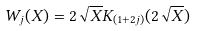<formula> <loc_0><loc_0><loc_500><loc_500>W _ { j } ( X ) = 2 { \sqrt { X } } K _ { ( 1 + 2 j ) } ( 2 \sqrt { X } )</formula> 